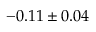<formula> <loc_0><loc_0><loc_500><loc_500>- 0 . 1 1 \pm 0 . 0 4</formula> 